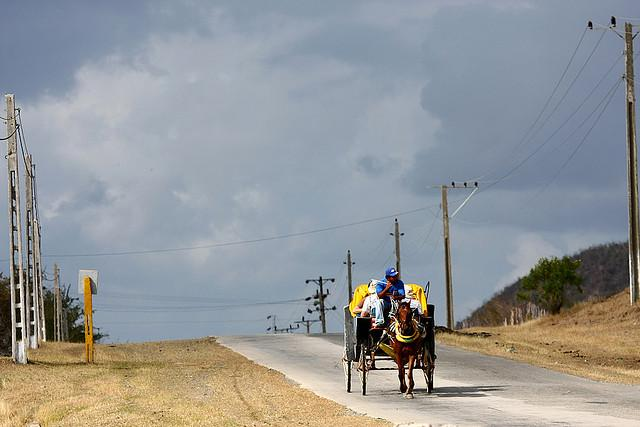What is the tallest item here? telephone poles 